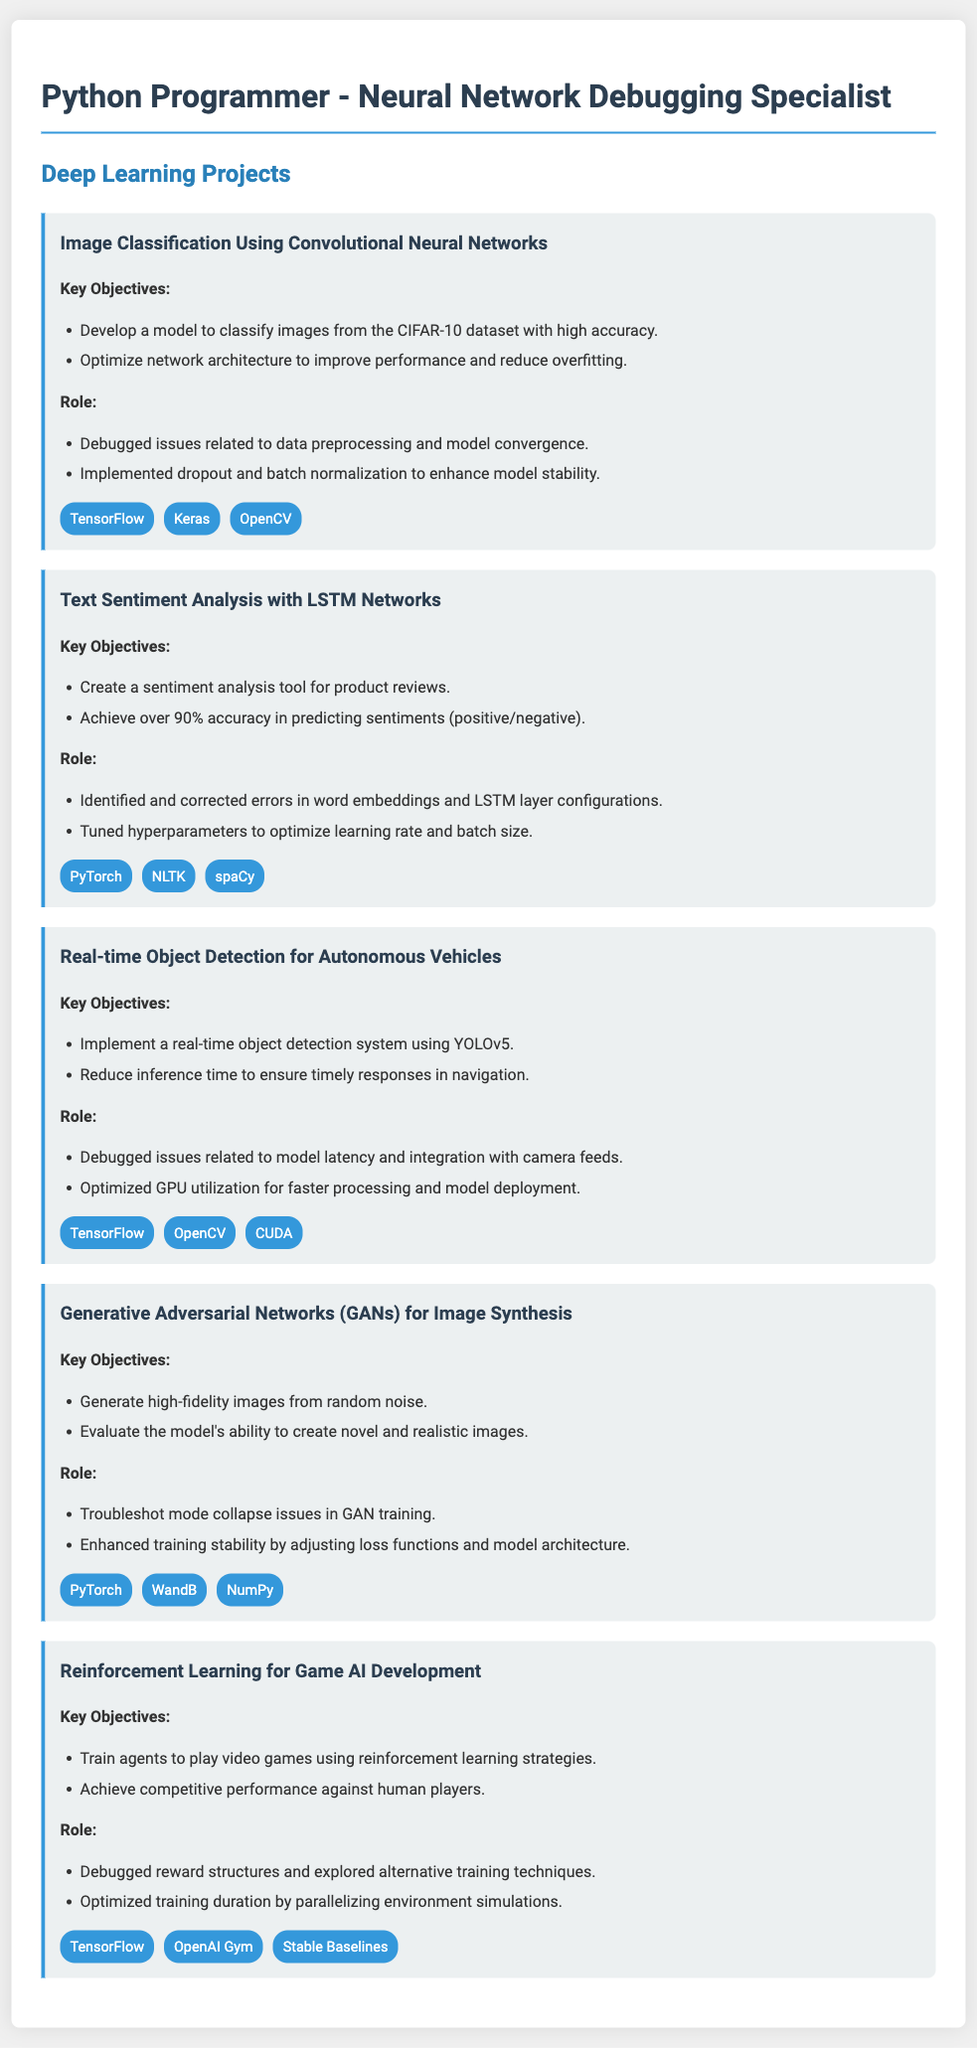what is the first project listed? The first project listed in the document is about classifying images using Convolutional Neural Networks.
Answer: Image Classification Using Convolutional Neural Networks how many projects are detailed in the document? The document details five different deep learning projects.
Answer: Five which technology is used in the Real-time Object Detection project? The technology used in the Real-time Object Detection project includes YOLOv5 and other tools for implementation.
Answer: YOLOv5 what is the main objective of the Text Sentiment Analysis project? The main objective of the Text Sentiment Analysis project is to create a sentiment analysis tool for product reviews.
Answer: Create a sentiment analysis tool for product reviews which role is consistently emphasized across all projects? The role consistently emphasized across all projects is debugging issues and optimizing model performance.
Answer: Debugging issues and optimizing model performance what was the focus of the Generative Adversarial Networks project? The focus of the Generative Adversarial Networks project was to generate high-fidelity images from random noise.
Answer: Generate high-fidelity images from random noise which framework is used for the Reinforcement Learning project? The framework used for the Reinforcement Learning project is TensorFlow among others.
Answer: TensorFlow what was the target accuracy for the sentiment analysis tool? The target accuracy for the sentiment analysis tool was to achieve over 90%.
Answer: Over 90% 